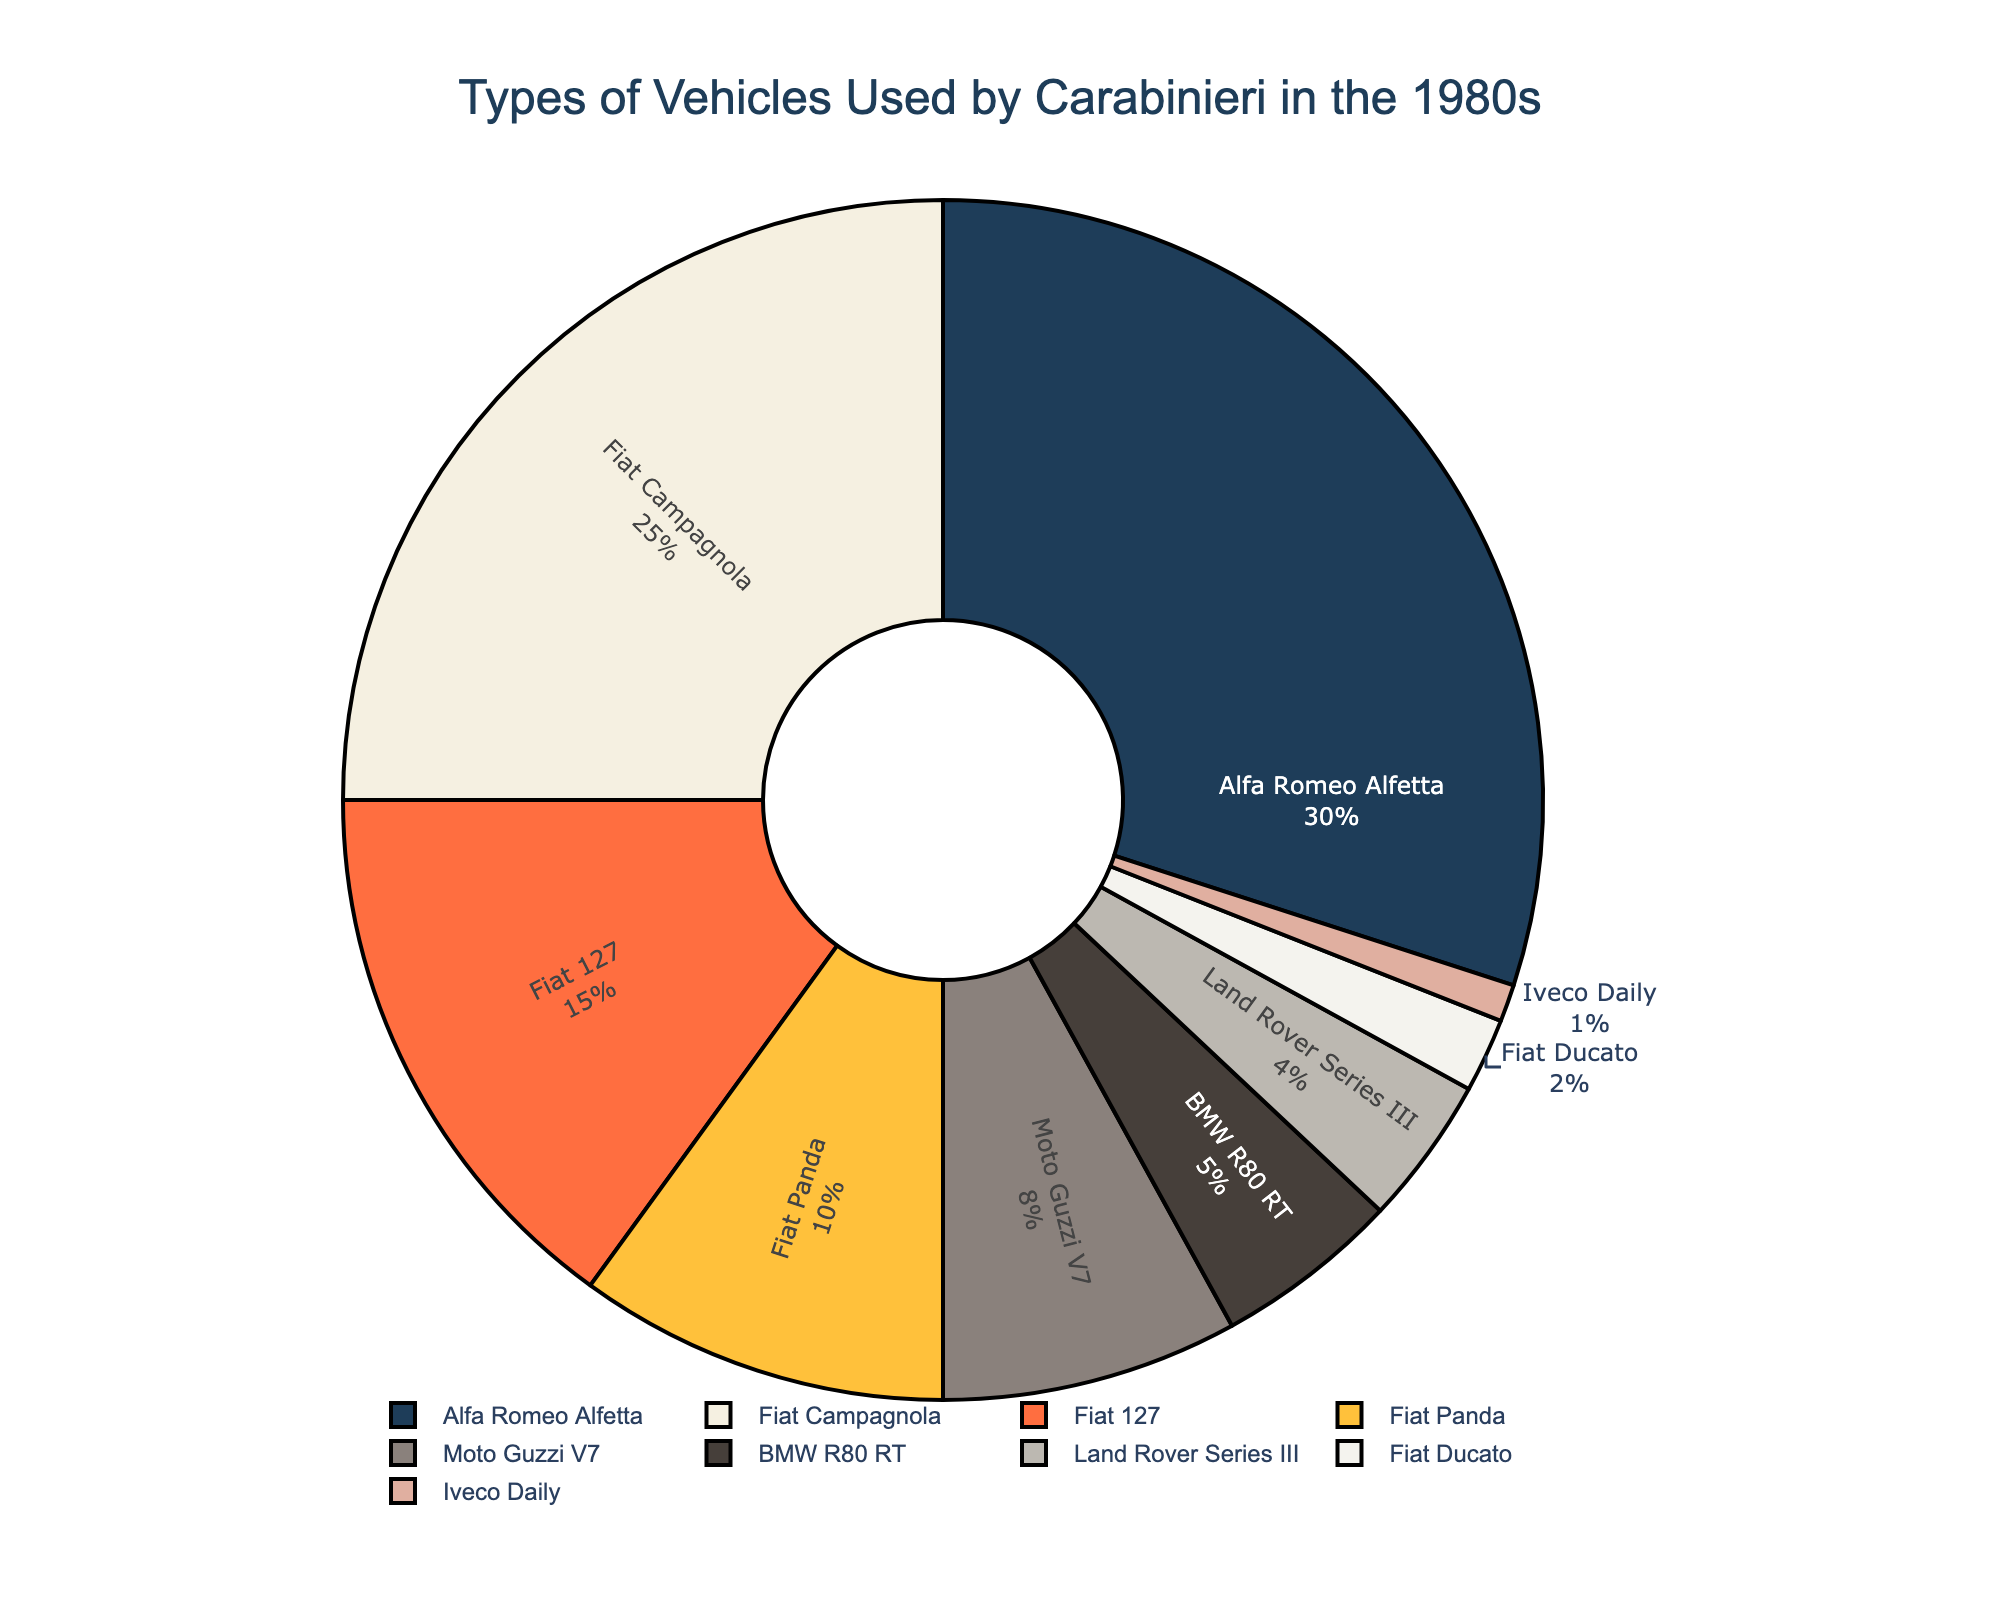Which vehicle type was used the most by Carabinieri in the 1980s? The pie chart shows the percentage of each vehicle type used by Carabinieri. The Alfa Romeo Alfetta has the largest percentage at 30%.
Answer: Alfa Romeo Alfetta What is the total percentage of Fiat vehicles used by Carabinieri in the 1980s? The pie chart shows percentages for each Fiat vehicle: Fiat Campagnola (25%), Fiat 127 (15%), Fiat Panda (10%), Fiat Ducato (2%). Adding these gives 25% + 15% + 10% + 2% = 52%.
Answer: 52% Which motorcycle was used more by Carabinieri, Moto Guzzi V7 or BMW R80 RT? According to the pie chart, Moto Guzzi V7 accounts for 8% while BMW R80 RT accounts for 5%. Therefore, Moto Guzzi V7 was used more.
Answer: Moto Guzzi V7 What is the combined percentage for Alfa Romeo Alfetta and Fiat Campagnola? The pie chart indicates that the Alfa Romeo Alfetta accounts for 30% and the Fiat Campagnola accounts for 25%. Adding these together gives 30% + 25% = 55%.
Answer: 55% Is there a larger percentage of Moto Guzzi V7 or Land Rover Series III vehicles? The pie chart shows 8% for Moto Guzzi V7 and 4% for Land Rover Series III. Therefore, Moto Guzzi V7 has a larger percentage.
Answer: Moto Guzzi V7 Which vehicle type has the smallest percentage usage by Carabinieri? The pie chart indicates that the Iveco Daily has the smallest percentage at 1%.
Answer: Iveco Daily What is the difference in percentage between Fiat Pandas and BMW R80 RTs used? The pie chart shows that Fiat Panda is 10% and BMW R80 RT is 5%. The difference is 10% - 5% = 5%.
Answer: 5% What is the combined percentage for all the vehicles that are not motorcycles? Non-motorcycle vehicles percentages are: Alfa Romeo Alfetta (30%), Fiat Campagnola (25%), Fiat 127 (15%), Fiat Panda (10%), Land Rover Series III (4%), Fiat Ducato (2%), Iveco Daily (1%). Adding these gives 30% + 25% + 15% + 10% + 4% + 2% + 1% = 87%.
Answer: 87% What is the average percentage of usage for the Fiat vehicles? Fiat vehicles and their percentages are: Fiat Campagnola (25%), Fiat 127 (15%), Fiat Panda (10%), and Fiat Ducato (2%). Adding these gives 52%, and there are 4 vehicles, so the average is 52% / 4 = 13%.
Answer: 13% Which vehicle types have a percentage that is less than 5%? From the pie chart, the vehicle types with percentages less than 5% are the Land Rover Series III (4%) and Iveco Daily (1%).
Answer: Land Rover Series III and Iveco Daily 